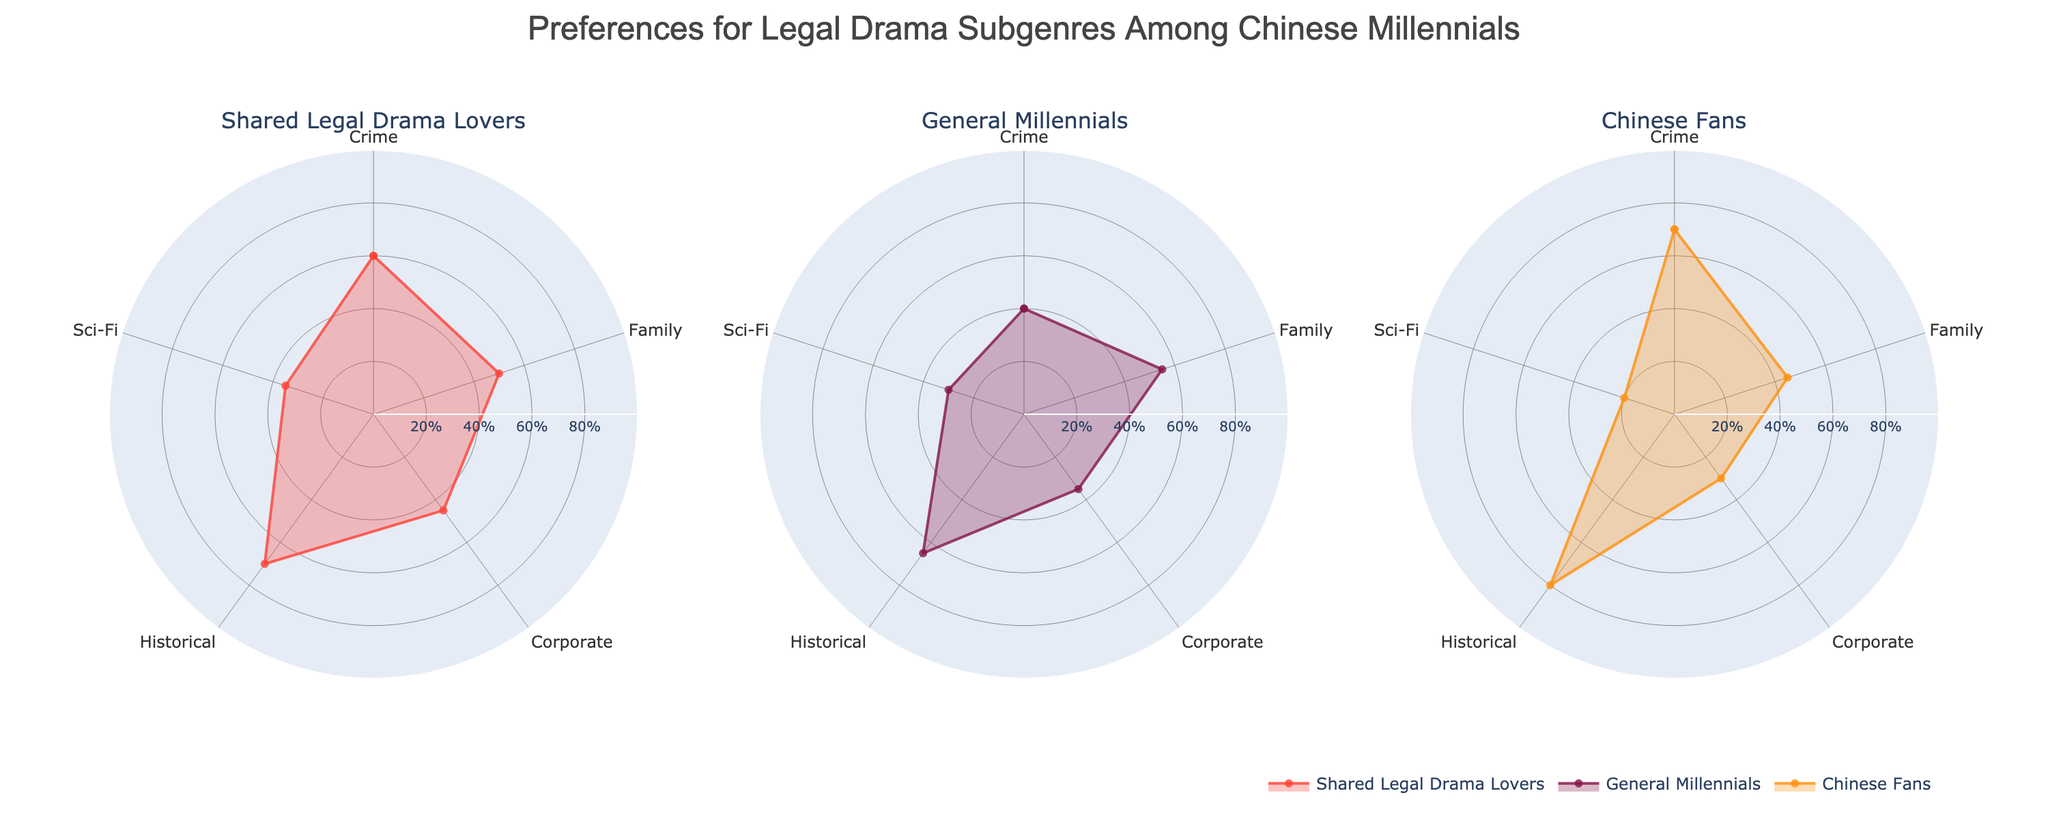What is the title of the figure? The title is displayed at the top of the figure. It reads "Preferences for Legal Drama Subgenres Among Chinese Millennials".
Answer: Preferences for Legal Drama Subgenres Among Chinese Millennials Which subgenre is most liked by Chinese Fans? According to the radar chart in the "Chinese Fans" subplot, the highest percentage is for Historical subgenre at 80%.
Answer: Historical Which subgenre has the highest percentage of preferences among General Millennials? In the "General Millennials" subplot, the Historical subgenre has the highest percentage at 65%.
Answer: Historical How does the preference for Family dramas compare between Shared Legal Drama Lovers and Chinese Fans? In the radar chart, Shared Legal Drama Lovers show a 50% preference for Family dramas, while Chinese Fans show a 45% preference. Hence, Shared Legal Drama Lovers have a slightly higher preference.
Answer: Shared Legal Drama Lovers (50% vs 45%) Which subgenre shows the biggest difference in preferences between Chinese Fans and General Millennials? The subgenre with the biggest difference is Historical, with an 80% preference among Chinese Fans and a 65% preference among General Millennials. The difference is 15%.
Answer: Historical (15%) What is the percentage difference in Sci-Fi preferences between Shared Legal Drama Lovers and Chinese Fans? According to the radar chart, Shared Legal Drama Lovers have 35% preference, while Chinese Fans have 20% preference. The difference is 15%.
Answer: 15% Which group has the least interest in Corporate dramas? The "Chinese Fans" subplot shows the lowest interest in Corporate dramas, with a percentage of 30%.
Answer: Chinese Fans Compare the preference percentages of the Crime subgenre among all three groups. The Crime subgenre preferences are 60% for Shared Legal Drama Lovers, 40% for General Millennials, and 70% for Chinese Fans.
Answer: Shared Legal Drama Lovers: 60%, General Millennials: 40%, Chinese Fans: 70% What can be deduced about the preference trends for Historical dramas across all three groups? Historical dramas are consistently the most preferred subgenre across all groups, with preferences being 70% for Shared Legal Drama Lovers, 65% for General Millennials, and 80% for Chinese Fans.
Answer: Most preferred in all groups Which subgenre shows the least variation in preferences among the three groups? The Family subgenre shows the least variation, with percentages being 50% for Shared Legal Drama Lovers, 55% for General Millennials, and 45% for Chinese Fans. The variation is minimal compared to other subgenres.
Answer: Family 